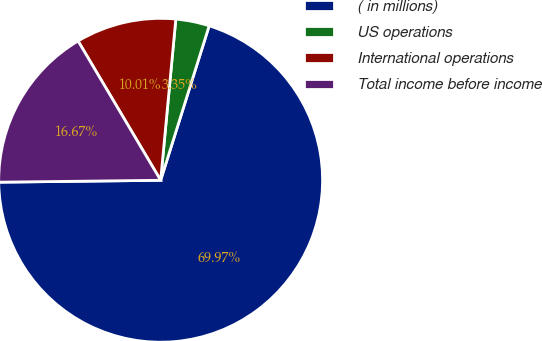<chart> <loc_0><loc_0><loc_500><loc_500><pie_chart><fcel>( in millions)<fcel>US operations<fcel>International operations<fcel>Total income before income<nl><fcel>69.97%<fcel>3.35%<fcel>10.01%<fcel>16.67%<nl></chart> 